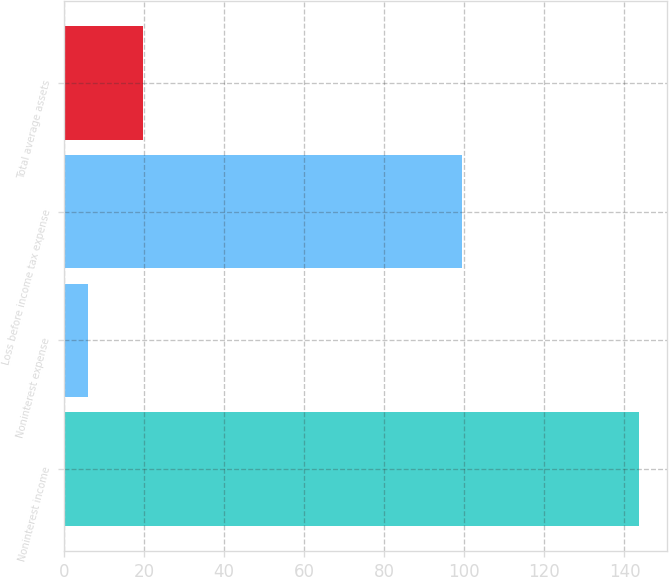Convert chart. <chart><loc_0><loc_0><loc_500><loc_500><bar_chart><fcel>Noninterest income<fcel>Noninterest expense<fcel>Loss before income tax expense<fcel>Total average assets<nl><fcel>143.5<fcel>6<fcel>99.3<fcel>19.75<nl></chart> 